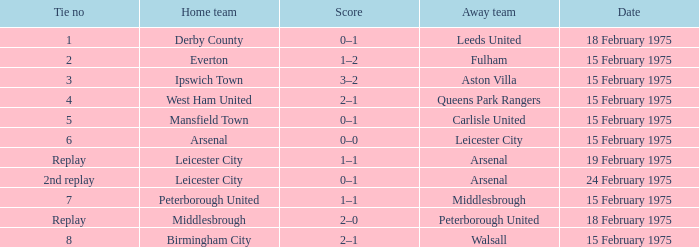What was the tie number when peterborough united was the away team? Replay. 